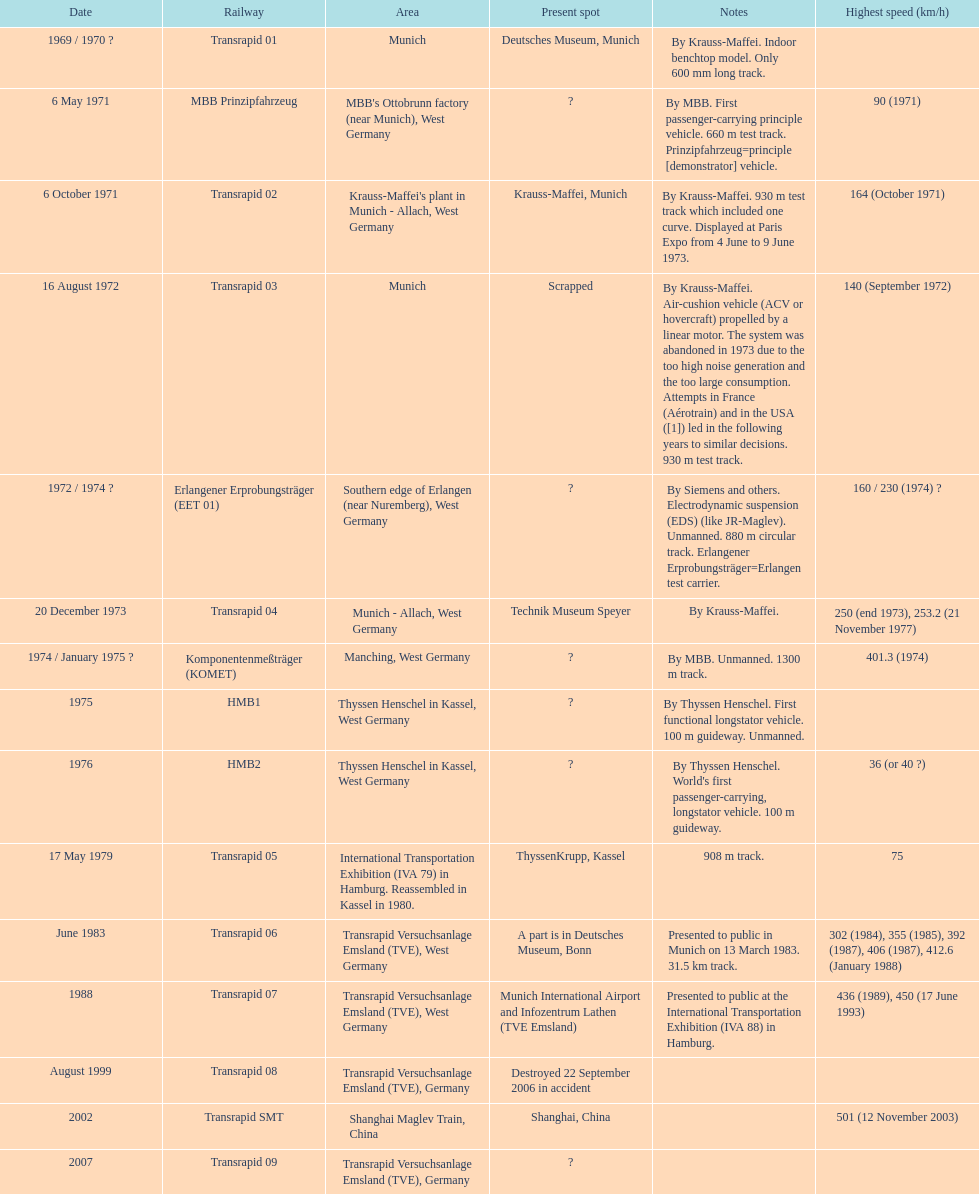What are all of the transrapid trains? Transrapid 01, Transrapid 02, Transrapid 03, Transrapid 04, Transrapid 05, Transrapid 06, Transrapid 07, Transrapid 08, Transrapid SMT, Transrapid 09. Of those, which train had to be scrapped? Transrapid 03. Give me the full table as a dictionary. {'header': ['Date', 'Railway', 'Area', 'Present spot', 'Notes', 'Highest speed (km/h)'], 'rows': [['1969 / 1970\xa0?', 'Transrapid 01', 'Munich', 'Deutsches Museum, Munich', 'By Krauss-Maffei. Indoor benchtop model. Only 600\xa0mm long track.', ''], ['6 May 1971', 'MBB Prinzipfahrzeug', "MBB's Ottobrunn factory (near Munich), West Germany", '?', 'By MBB. First passenger-carrying principle vehicle. 660 m test track. Prinzipfahrzeug=principle [demonstrator] vehicle.', '90 (1971)'], ['6 October 1971', 'Transrapid 02', "Krauss-Maffei's plant in Munich - Allach, West Germany", 'Krauss-Maffei, Munich', 'By Krauss-Maffei. 930 m test track which included one curve. Displayed at Paris Expo from 4 June to 9 June 1973.', '164 (October 1971)'], ['16 August 1972', 'Transrapid 03', 'Munich', 'Scrapped', 'By Krauss-Maffei. Air-cushion vehicle (ACV or hovercraft) propelled by a linear motor. The system was abandoned in 1973 due to the too high noise generation and the too large consumption. Attempts in France (Aérotrain) and in the USA ([1]) led in the following years to similar decisions. 930 m test track.', '140 (September 1972)'], ['1972 / 1974\xa0?', 'Erlangener Erprobungsträger (EET 01)', 'Southern edge of Erlangen (near Nuremberg), West Germany', '?', 'By Siemens and others. Electrodynamic suspension (EDS) (like JR-Maglev). Unmanned. 880 m circular track. Erlangener Erprobungsträger=Erlangen test carrier.', '160 / 230 (1974)\xa0?'], ['20 December 1973', 'Transrapid 04', 'Munich - Allach, West Germany', 'Technik Museum Speyer', 'By Krauss-Maffei.', '250 (end 1973), 253.2 (21 November 1977)'], ['1974 / January 1975\xa0?', 'Komponentenmeßträger (KOMET)', 'Manching, West Germany', '?', 'By MBB. Unmanned. 1300 m track.', '401.3 (1974)'], ['1975', 'HMB1', 'Thyssen Henschel in Kassel, West Germany', '?', 'By Thyssen Henschel. First functional longstator vehicle. 100 m guideway. Unmanned.', ''], ['1976', 'HMB2', 'Thyssen Henschel in Kassel, West Germany', '?', "By Thyssen Henschel. World's first passenger-carrying, longstator vehicle. 100 m guideway.", '36 (or 40\xa0?)'], ['17 May 1979', 'Transrapid 05', 'International Transportation Exhibition (IVA 79) in Hamburg. Reassembled in Kassel in 1980.', 'ThyssenKrupp, Kassel', '908 m track.', '75'], ['June 1983', 'Transrapid 06', 'Transrapid Versuchsanlage Emsland (TVE), West Germany', 'A part is in Deutsches Museum, Bonn', 'Presented to public in Munich on 13 March 1983. 31.5\xa0km track.', '302 (1984), 355 (1985), 392 (1987), 406 (1987), 412.6 (January 1988)'], ['1988', 'Transrapid 07', 'Transrapid Versuchsanlage Emsland (TVE), West Germany', 'Munich International Airport and Infozentrum Lathen (TVE Emsland)', 'Presented to public at the International Transportation Exhibition (IVA 88) in Hamburg.', '436 (1989), 450 (17 June 1993)'], ['August 1999', 'Transrapid 08', 'Transrapid Versuchsanlage Emsland (TVE), Germany', 'Destroyed 22 September 2006 in accident', '', ''], ['2002', 'Transrapid SMT', 'Shanghai Maglev Train, China', 'Shanghai, China', '', '501 (12 November 2003)'], ['2007', 'Transrapid 09', 'Transrapid Versuchsanlage Emsland (TVE), Germany', '?', '', '']]} 